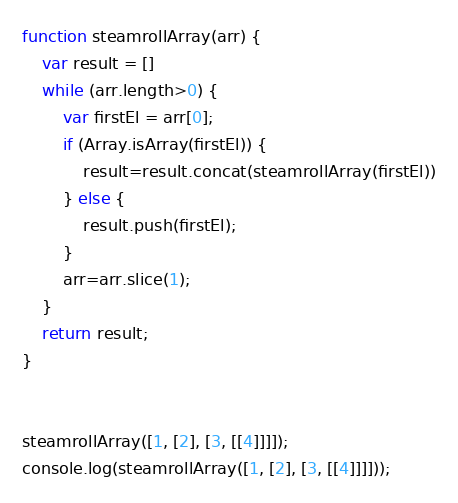<code> <loc_0><loc_0><loc_500><loc_500><_JavaScript_>
function steamrollArray(arr) {
    var result = []
    while (arr.length>0) {
        var firstEl = arr[0];
        if (Array.isArray(firstEl)) {
            result=result.concat(steamrollArray(firstEl))
        } else {
            result.push(firstEl);
        }
        arr=arr.slice(1);
    }
    return result;
}


steamrollArray([1, [2], [3, [[4]]]]);
console.log(steamrollArray([1, [2], [3, [[4]]]]));
</code> 